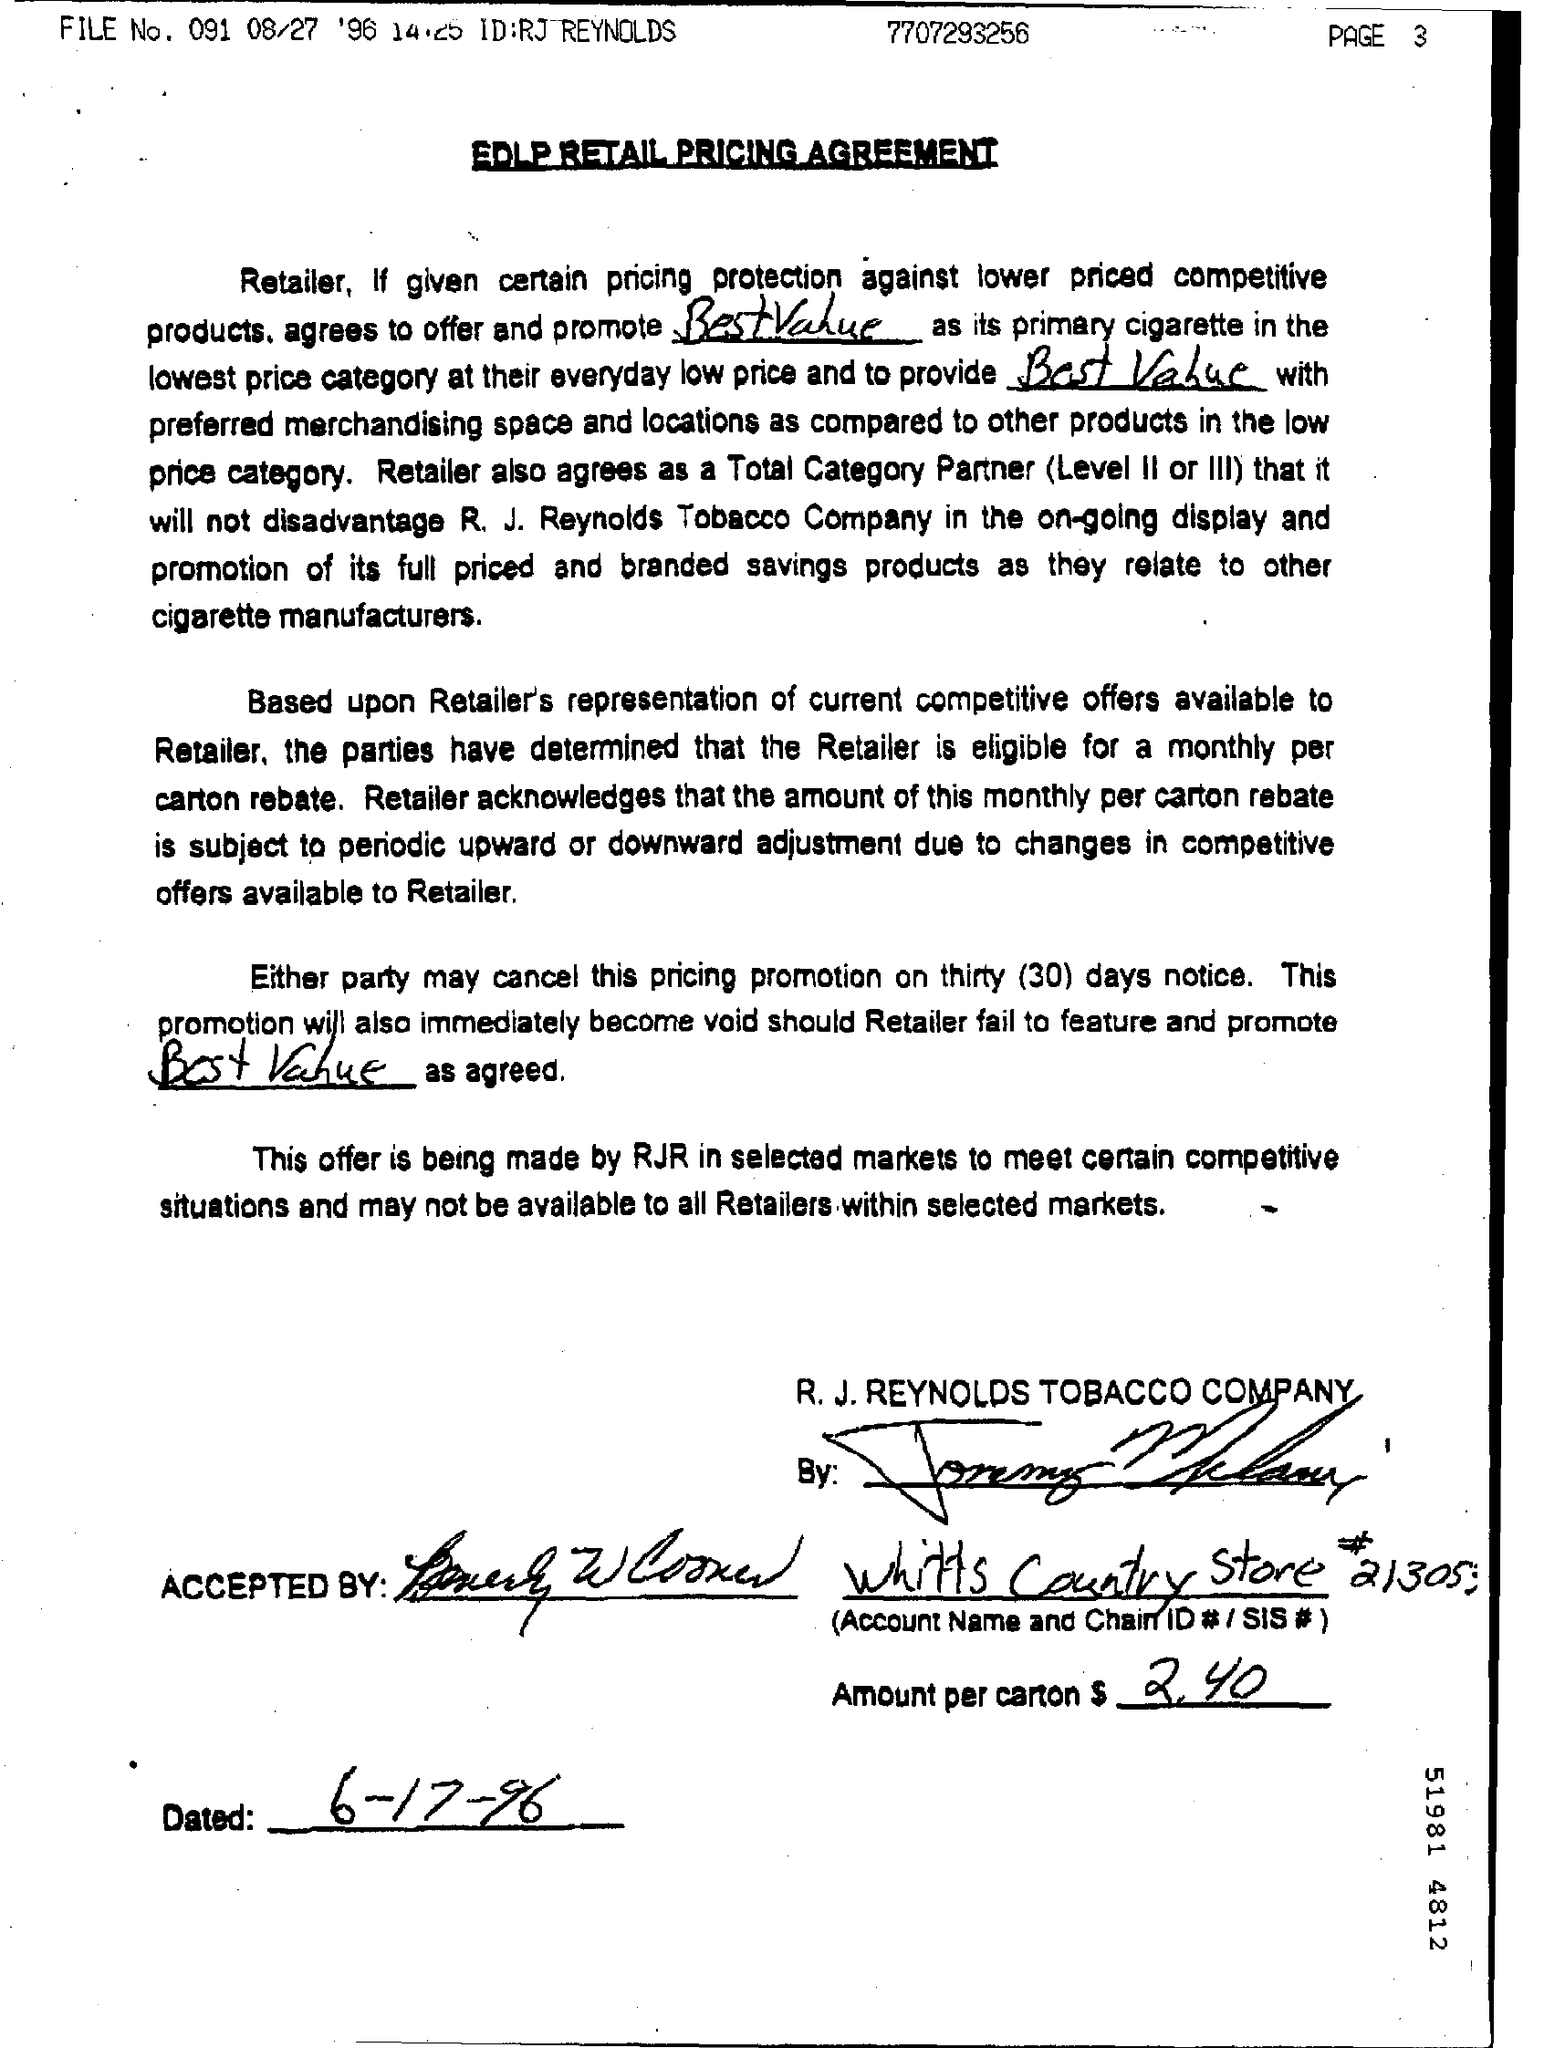What is the Title of the document?
Make the answer very short. Edlp retail pricing agreement. What is the File No.?
Make the answer very short. 091. When is it  Dated for?
Offer a very short reply. 6-17-96. What is the ID?
Your response must be concise. Rj reynolds. What is the Amount per carton?
Keep it short and to the point. $ 2.40. What is the Document Number?
Your answer should be very brief. 7707293256. 